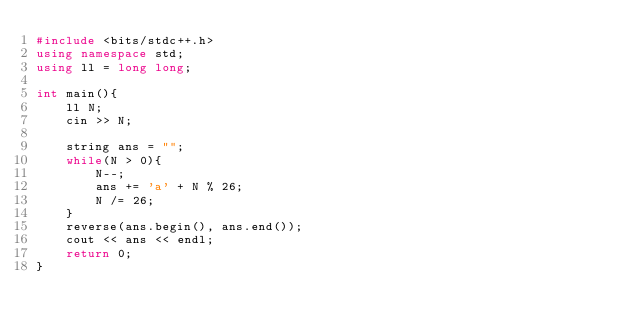Convert code to text. <code><loc_0><loc_0><loc_500><loc_500><_C++_>#include <bits/stdc++.h>
using namespace std;
using ll = long long;
 
int main(){
    ll N;
    cin >> N;

    string ans = "";
    while(N > 0){
        N--;
        ans += 'a' + N % 26;
        N /= 26;
    }
    reverse(ans.begin(), ans.end());
    cout << ans << endl;
    return 0;
}</code> 